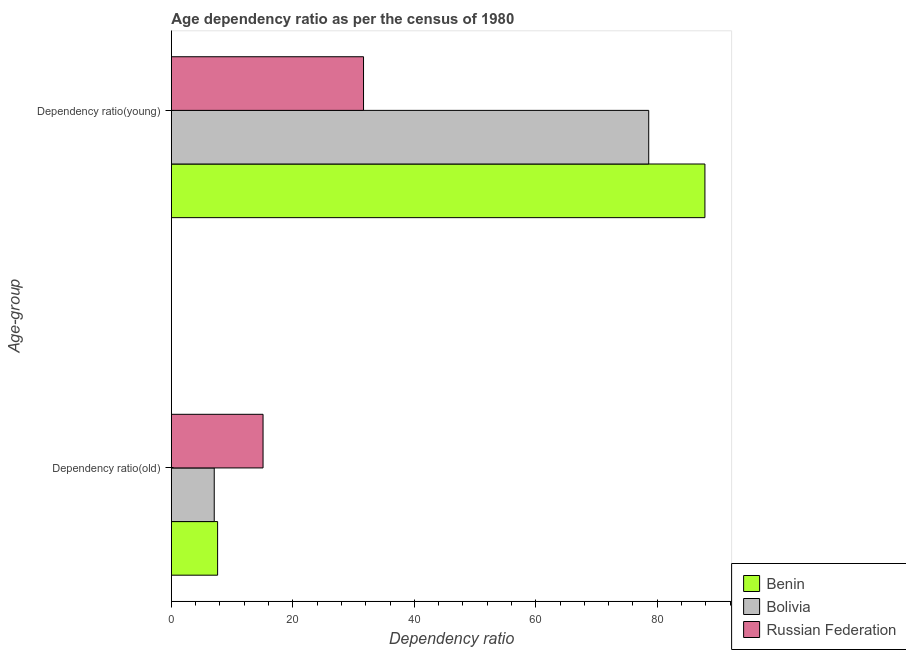How many different coloured bars are there?
Provide a short and direct response. 3. How many groups of bars are there?
Your answer should be very brief. 2. Are the number of bars per tick equal to the number of legend labels?
Offer a terse response. Yes. Are the number of bars on each tick of the Y-axis equal?
Offer a terse response. Yes. How many bars are there on the 1st tick from the top?
Offer a very short reply. 3. What is the label of the 2nd group of bars from the top?
Ensure brevity in your answer.  Dependency ratio(old). What is the age dependency ratio(old) in Bolivia?
Keep it short and to the point. 7.06. Across all countries, what is the maximum age dependency ratio(old)?
Keep it short and to the point. 15.09. Across all countries, what is the minimum age dependency ratio(young)?
Offer a terse response. 31.64. In which country was the age dependency ratio(young) maximum?
Ensure brevity in your answer.  Benin. What is the total age dependency ratio(old) in the graph?
Your response must be concise. 29.76. What is the difference between the age dependency ratio(young) in Russian Federation and that in Benin?
Provide a short and direct response. -56.21. What is the difference between the age dependency ratio(old) in Benin and the age dependency ratio(young) in Bolivia?
Keep it short and to the point. -70.98. What is the average age dependency ratio(young) per country?
Your answer should be compact. 66.03. What is the difference between the age dependency ratio(young) and age dependency ratio(old) in Russian Federation?
Make the answer very short. 16.54. In how many countries, is the age dependency ratio(old) greater than 60 ?
Keep it short and to the point. 0. What is the ratio of the age dependency ratio(old) in Russian Federation to that in Bolivia?
Your answer should be very brief. 2.14. Is the age dependency ratio(young) in Benin less than that in Bolivia?
Provide a succinct answer. No. In how many countries, is the age dependency ratio(young) greater than the average age dependency ratio(young) taken over all countries?
Provide a succinct answer. 2. What does the 1st bar from the top in Dependency ratio(old) represents?
Keep it short and to the point. Russian Federation. What does the 1st bar from the bottom in Dependency ratio(young) represents?
Ensure brevity in your answer.  Benin. How many bars are there?
Make the answer very short. 6. Are the values on the major ticks of X-axis written in scientific E-notation?
Provide a short and direct response. No. How are the legend labels stacked?
Offer a terse response. Vertical. What is the title of the graph?
Ensure brevity in your answer.  Age dependency ratio as per the census of 1980. Does "Netherlands" appear as one of the legend labels in the graph?
Your response must be concise. No. What is the label or title of the X-axis?
Give a very brief answer. Dependency ratio. What is the label or title of the Y-axis?
Keep it short and to the point. Age-group. What is the Dependency ratio in Benin in Dependency ratio(old)?
Make the answer very short. 7.61. What is the Dependency ratio of Bolivia in Dependency ratio(old)?
Your answer should be very brief. 7.06. What is the Dependency ratio in Russian Federation in Dependency ratio(old)?
Ensure brevity in your answer.  15.09. What is the Dependency ratio of Benin in Dependency ratio(young)?
Provide a short and direct response. 87.85. What is the Dependency ratio of Bolivia in Dependency ratio(young)?
Your response must be concise. 78.59. What is the Dependency ratio of Russian Federation in Dependency ratio(young)?
Make the answer very short. 31.64. Across all Age-group, what is the maximum Dependency ratio in Benin?
Your response must be concise. 87.85. Across all Age-group, what is the maximum Dependency ratio in Bolivia?
Offer a terse response. 78.59. Across all Age-group, what is the maximum Dependency ratio in Russian Federation?
Ensure brevity in your answer.  31.64. Across all Age-group, what is the minimum Dependency ratio of Benin?
Make the answer very short. 7.61. Across all Age-group, what is the minimum Dependency ratio of Bolivia?
Ensure brevity in your answer.  7.06. Across all Age-group, what is the minimum Dependency ratio in Russian Federation?
Offer a terse response. 15.09. What is the total Dependency ratio of Benin in the graph?
Your response must be concise. 95.46. What is the total Dependency ratio in Bolivia in the graph?
Ensure brevity in your answer.  85.65. What is the total Dependency ratio of Russian Federation in the graph?
Your answer should be compact. 46.73. What is the difference between the Dependency ratio of Benin in Dependency ratio(old) and that in Dependency ratio(young)?
Offer a very short reply. -80.24. What is the difference between the Dependency ratio of Bolivia in Dependency ratio(old) and that in Dependency ratio(young)?
Keep it short and to the point. -71.54. What is the difference between the Dependency ratio of Russian Federation in Dependency ratio(old) and that in Dependency ratio(young)?
Offer a very short reply. -16.54. What is the difference between the Dependency ratio of Benin in Dependency ratio(old) and the Dependency ratio of Bolivia in Dependency ratio(young)?
Make the answer very short. -70.98. What is the difference between the Dependency ratio in Benin in Dependency ratio(old) and the Dependency ratio in Russian Federation in Dependency ratio(young)?
Your response must be concise. -24.02. What is the difference between the Dependency ratio of Bolivia in Dependency ratio(old) and the Dependency ratio of Russian Federation in Dependency ratio(young)?
Offer a terse response. -24.58. What is the average Dependency ratio in Benin per Age-group?
Offer a terse response. 47.73. What is the average Dependency ratio of Bolivia per Age-group?
Your answer should be compact. 42.82. What is the average Dependency ratio of Russian Federation per Age-group?
Provide a short and direct response. 23.37. What is the difference between the Dependency ratio of Benin and Dependency ratio of Bolivia in Dependency ratio(old)?
Your answer should be very brief. 0.56. What is the difference between the Dependency ratio in Benin and Dependency ratio in Russian Federation in Dependency ratio(old)?
Your response must be concise. -7.48. What is the difference between the Dependency ratio of Bolivia and Dependency ratio of Russian Federation in Dependency ratio(old)?
Your response must be concise. -8.04. What is the difference between the Dependency ratio of Benin and Dependency ratio of Bolivia in Dependency ratio(young)?
Offer a very short reply. 9.26. What is the difference between the Dependency ratio in Benin and Dependency ratio in Russian Federation in Dependency ratio(young)?
Offer a terse response. 56.21. What is the difference between the Dependency ratio in Bolivia and Dependency ratio in Russian Federation in Dependency ratio(young)?
Provide a succinct answer. 46.96. What is the ratio of the Dependency ratio of Benin in Dependency ratio(old) to that in Dependency ratio(young)?
Offer a very short reply. 0.09. What is the ratio of the Dependency ratio of Bolivia in Dependency ratio(old) to that in Dependency ratio(young)?
Your response must be concise. 0.09. What is the ratio of the Dependency ratio of Russian Federation in Dependency ratio(old) to that in Dependency ratio(young)?
Your response must be concise. 0.48. What is the difference between the highest and the second highest Dependency ratio of Benin?
Keep it short and to the point. 80.24. What is the difference between the highest and the second highest Dependency ratio in Bolivia?
Give a very brief answer. 71.54. What is the difference between the highest and the second highest Dependency ratio in Russian Federation?
Provide a succinct answer. 16.54. What is the difference between the highest and the lowest Dependency ratio in Benin?
Make the answer very short. 80.24. What is the difference between the highest and the lowest Dependency ratio in Bolivia?
Give a very brief answer. 71.54. What is the difference between the highest and the lowest Dependency ratio in Russian Federation?
Provide a succinct answer. 16.54. 